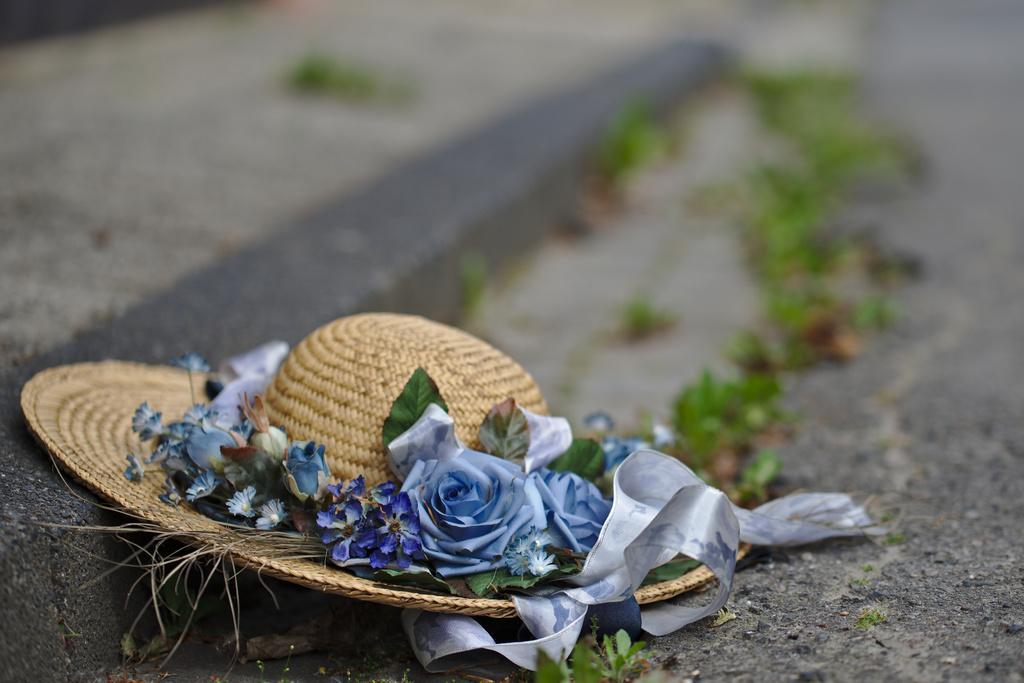Could you give a brief overview of what you see in this image? In this image there is a hat on the ground. In the background few leaves are visible. 